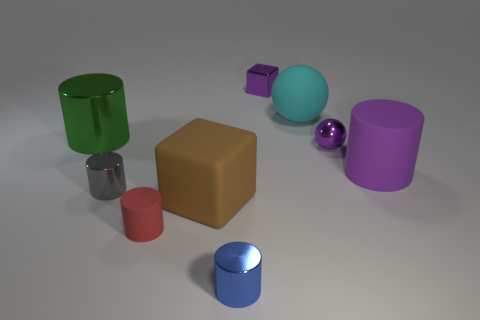Subtract all matte cylinders. How many cylinders are left? 3 Subtract all green cylinders. How many cylinders are left? 4 Subtract all blocks. How many objects are left? 7 Subtract 4 cylinders. How many cylinders are left? 1 Subtract all blue spheres. Subtract all red cylinders. How many spheres are left? 2 Subtract 1 cyan balls. How many objects are left? 8 Subtract all purple cylinders. How many yellow cubes are left? 0 Subtract all cyan blocks. Subtract all matte objects. How many objects are left? 5 Add 8 tiny purple shiny objects. How many tiny purple shiny objects are left? 10 Add 9 big green shiny blocks. How many big green shiny blocks exist? 9 